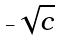<formula> <loc_0><loc_0><loc_500><loc_500>- \sqrt { c }</formula> 